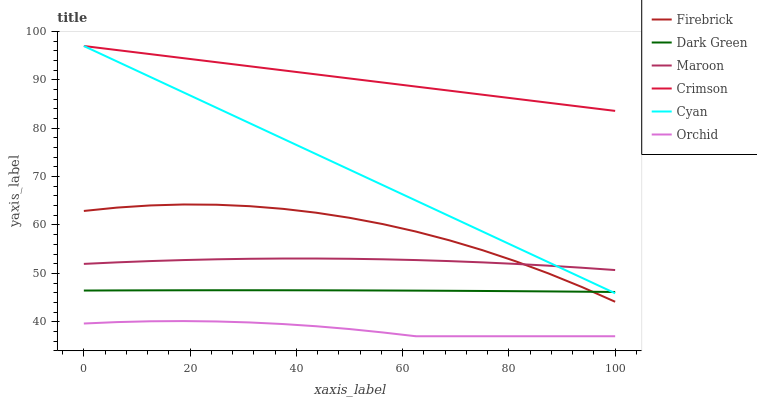Does Maroon have the minimum area under the curve?
Answer yes or no. No. Does Maroon have the maximum area under the curve?
Answer yes or no. No. Is Maroon the smoothest?
Answer yes or no. No. Is Maroon the roughest?
Answer yes or no. No. Does Maroon have the lowest value?
Answer yes or no. No. Does Maroon have the highest value?
Answer yes or no. No. Is Orchid less than Crimson?
Answer yes or no. Yes. Is Crimson greater than Firebrick?
Answer yes or no. Yes. Does Orchid intersect Crimson?
Answer yes or no. No. 